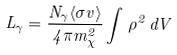Convert formula to latex. <formula><loc_0><loc_0><loc_500><loc_500>L _ { \gamma } = \frac { N _ { \gamma } \langle \sigma v \rangle } { 4 \pi m _ { \chi } ^ { 2 } } \int \, \rho ^ { 2 } \, d V</formula> 